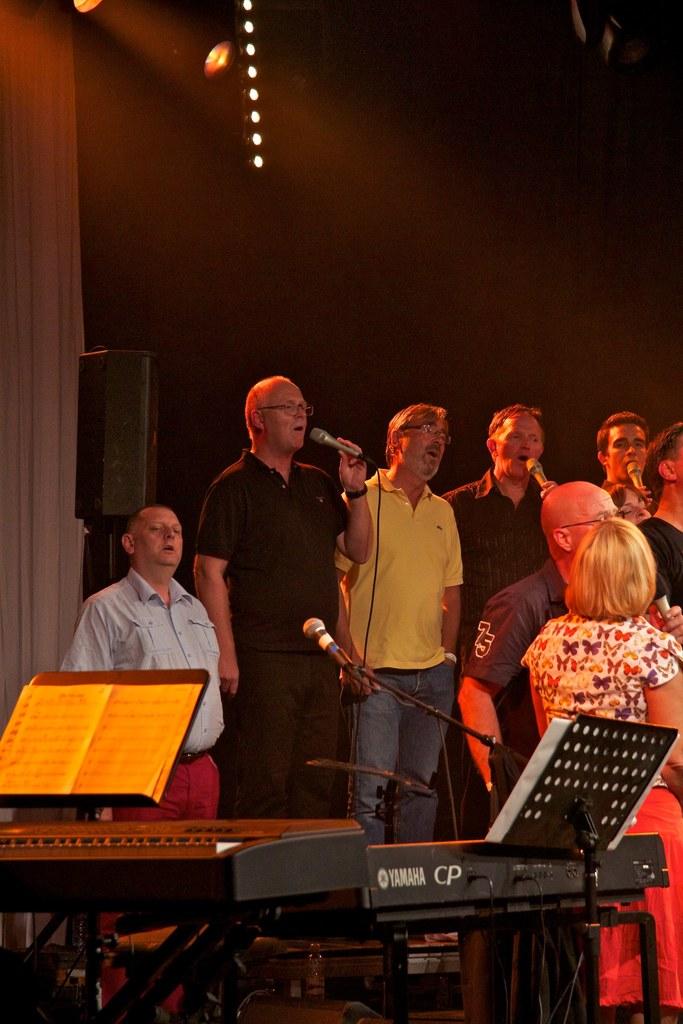What is the brand of the keyboard in the bottom right?
Keep it short and to the point. Yamaha. What number is on the man's shirt sleeve?
Your response must be concise. 75. 